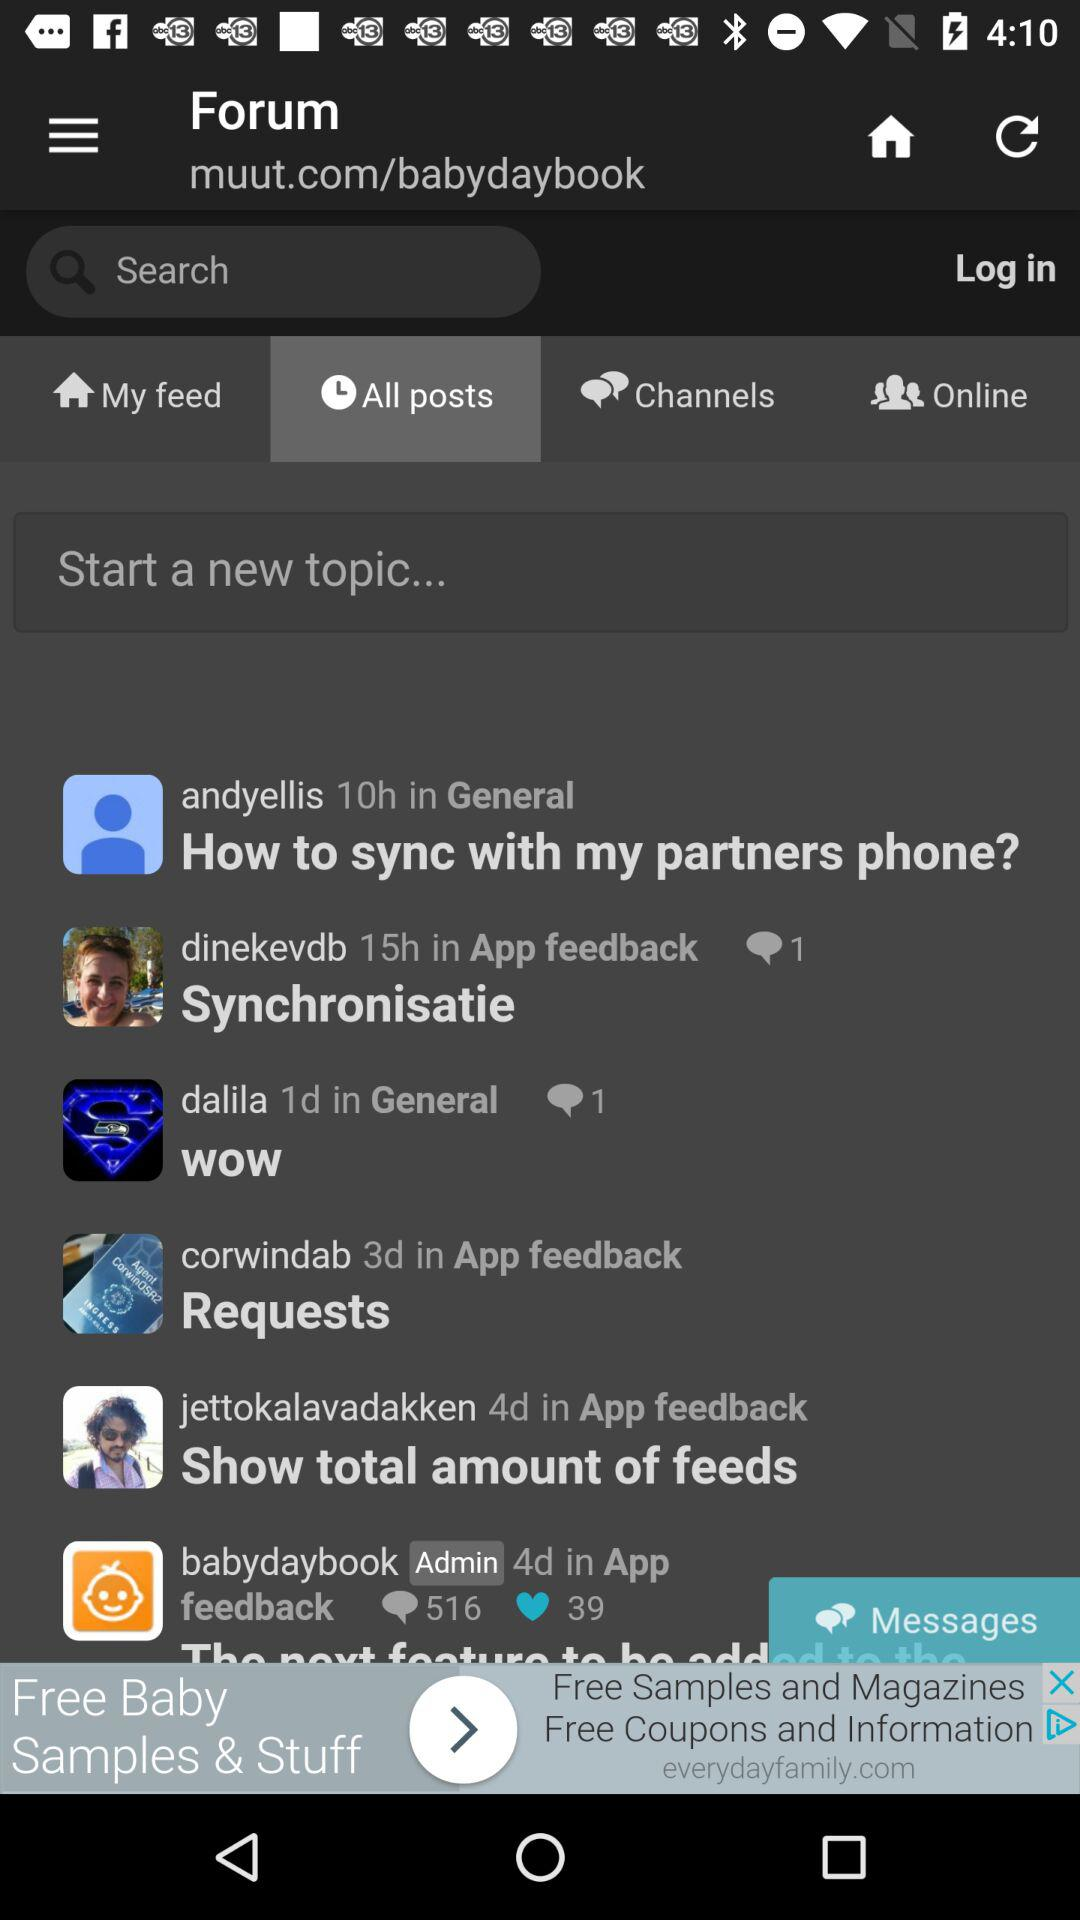Who is online?
When the provided information is insufficient, respond with <no answer>. <no answer> 